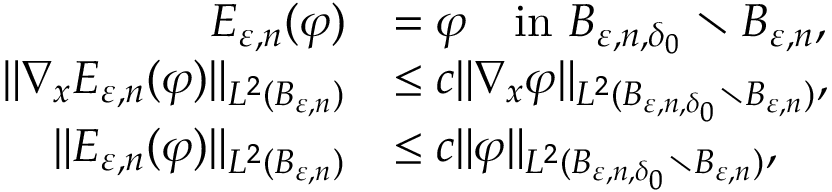Convert formula to latex. <formula><loc_0><loc_0><loc_500><loc_500>\begin{array} { r l } { E _ { \varepsilon , n } ( \varphi ) } & { = \varphi \quad i n B _ { \varepsilon , n , \delta _ { 0 } } \ B _ { \varepsilon , n } , } \\ { \| \nabla _ { x } E _ { \varepsilon , n } ( \varphi ) \| _ { L ^ { 2 } ( B _ { \varepsilon , n } ) } } & { \leq c \| \nabla _ { x } \varphi \| _ { L ^ { 2 } ( B _ { \varepsilon , n , \delta _ { 0 } } \ B _ { \varepsilon , n } ) } , } \\ { \| E _ { \varepsilon , n } ( \varphi ) \| _ { L ^ { 2 } ( B _ { \varepsilon , n } ) } } & { \leq c \| \varphi \| _ { L ^ { 2 } ( B _ { \varepsilon , n , \delta _ { 0 } } \ B _ { \varepsilon , n } ) } , } \end{array}</formula> 